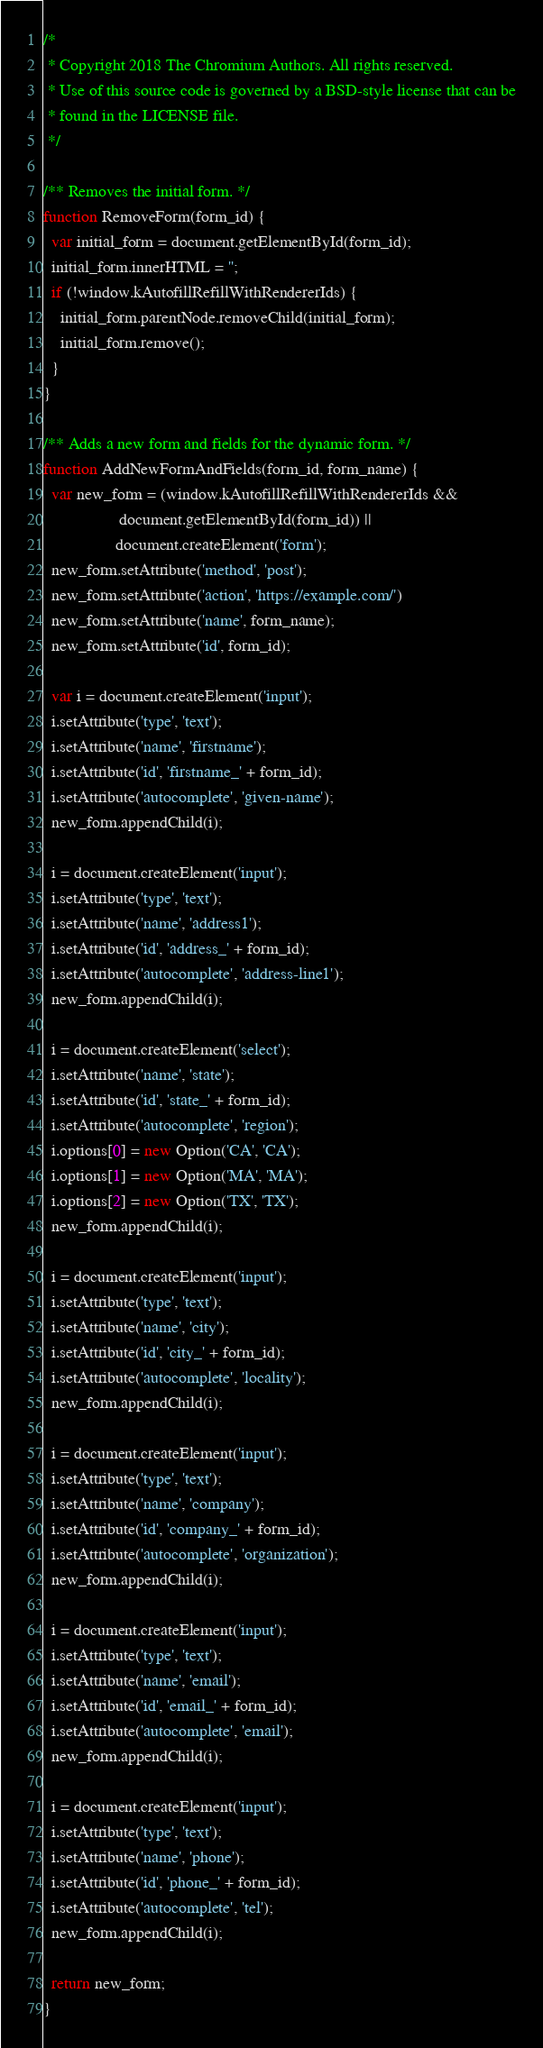<code> <loc_0><loc_0><loc_500><loc_500><_JavaScript_>/*
 * Copyright 2018 The Chromium Authors. All rights reserved.
 * Use of this source code is governed by a BSD-style license that can be
 * found in the LICENSE file.
 */

/** Removes the initial form. */
function RemoveForm(form_id) {
  var initial_form = document.getElementById(form_id);
  initial_form.innerHTML = '';
  if (!window.kAutofillRefillWithRendererIds) {
    initial_form.parentNode.removeChild(initial_form);
    initial_form.remove();
  }
}

/** Adds a new form and fields for the dynamic form. */
function AddNewFormAndFields(form_id, form_name) {
  var new_form = (window.kAutofillRefillWithRendererIds &&
                  document.getElementById(form_id)) ||
                 document.createElement('form');
  new_form.setAttribute('method', 'post');
  new_form.setAttribute('action', 'https://example.com/')
  new_form.setAttribute('name', form_name);
  new_form.setAttribute('id', form_id);

  var i = document.createElement('input');
  i.setAttribute('type', 'text');
  i.setAttribute('name', 'firstname');
  i.setAttribute('id', 'firstname_' + form_id);
  i.setAttribute('autocomplete', 'given-name');
  new_form.appendChild(i);

  i = document.createElement('input');
  i.setAttribute('type', 'text');
  i.setAttribute('name', 'address1');
  i.setAttribute('id', 'address_' + form_id);
  i.setAttribute('autocomplete', 'address-line1');
  new_form.appendChild(i);

  i = document.createElement('select');
  i.setAttribute('name', 'state');
  i.setAttribute('id', 'state_' + form_id);
  i.setAttribute('autocomplete', 'region');
  i.options[0] = new Option('CA', 'CA');
  i.options[1] = new Option('MA', 'MA');
  i.options[2] = new Option('TX', 'TX');
  new_form.appendChild(i);

  i = document.createElement('input');
  i.setAttribute('type', 'text');
  i.setAttribute('name', 'city');
  i.setAttribute('id', 'city_' + form_id);
  i.setAttribute('autocomplete', 'locality');
  new_form.appendChild(i);

  i = document.createElement('input');
  i.setAttribute('type', 'text');
  i.setAttribute('name', 'company');
  i.setAttribute('id', 'company_' + form_id);
  i.setAttribute('autocomplete', 'organization');
  new_form.appendChild(i);

  i = document.createElement('input');
  i.setAttribute('type', 'text');
  i.setAttribute('name', 'email');
  i.setAttribute('id', 'email_' + form_id);
  i.setAttribute('autocomplete', 'email');
  new_form.appendChild(i);

  i = document.createElement('input');
  i.setAttribute('type', 'text');
  i.setAttribute('name', 'phone');
  i.setAttribute('id', 'phone_' + form_id);
  i.setAttribute('autocomplete', 'tel');
  new_form.appendChild(i);

  return new_form;
}
</code> 